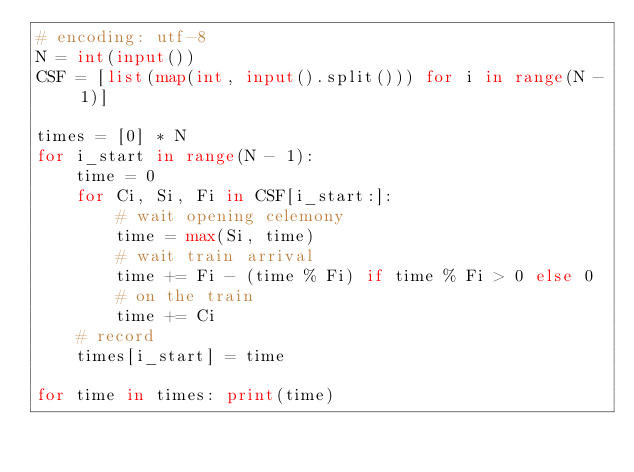Convert code to text. <code><loc_0><loc_0><loc_500><loc_500><_Python_># encoding: utf-8
N = int(input())
CSF = [list(map(int, input().split())) for i in range(N - 1)]

times = [0] * N
for i_start in range(N - 1):
    time = 0
    for Ci, Si, Fi in CSF[i_start:]:
        # wait opening celemony
        time = max(Si, time)
        # wait train arrival
        time += Fi - (time % Fi) if time % Fi > 0 else 0
        # on the train
        time += Ci
    # record
    times[i_start] = time

for time in times: print(time)</code> 